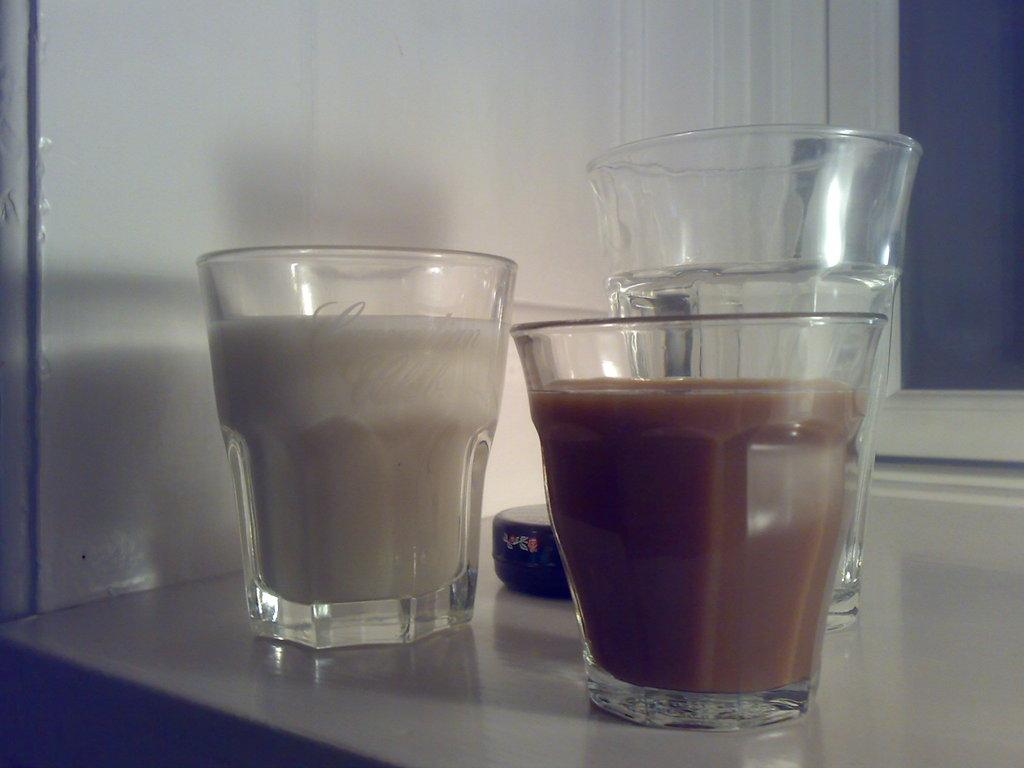What is contained in the glass that is visible in the image? There is a drink in the glass that is visible in the image. What other object can be seen in the image besides the glass? There is a black color object in the image. Where are the glass and the black color object located? Both the glass and the black color object are on a surface. What can be seen in the background of the image? There is a wall visible in the background of the image. Can you describe the alley where the bat is flying in the image? There is no alley or bat present in the image; it only features a glass with a drink, a black color object, and a wall in the background. 